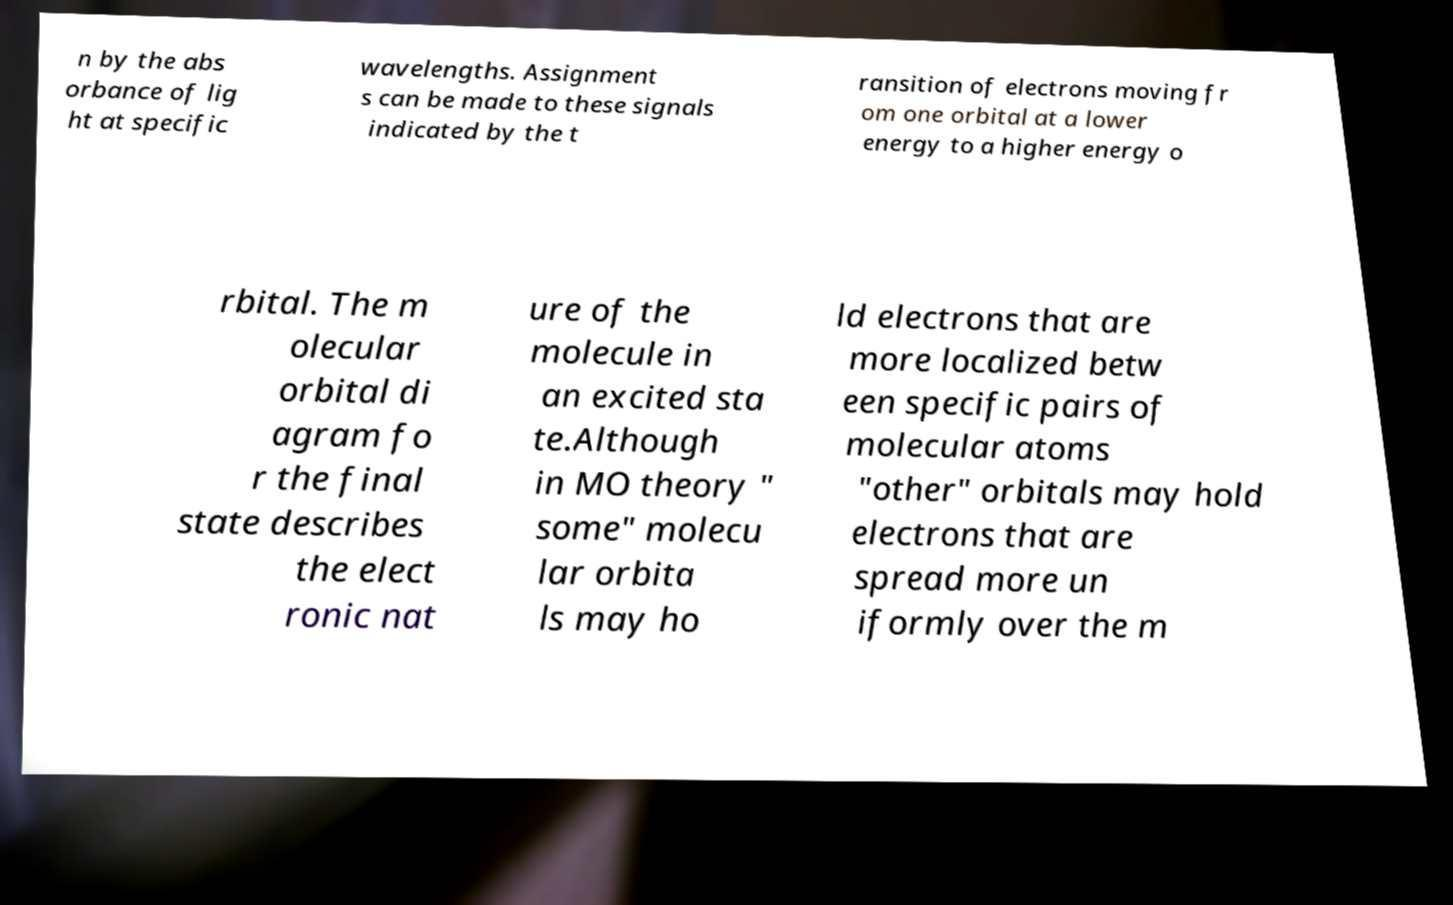There's text embedded in this image that I need extracted. Can you transcribe it verbatim? n by the abs orbance of lig ht at specific wavelengths. Assignment s can be made to these signals indicated by the t ransition of electrons moving fr om one orbital at a lower energy to a higher energy o rbital. The m olecular orbital di agram fo r the final state describes the elect ronic nat ure of the molecule in an excited sta te.Although in MO theory " some" molecu lar orbita ls may ho ld electrons that are more localized betw een specific pairs of molecular atoms "other" orbitals may hold electrons that are spread more un iformly over the m 